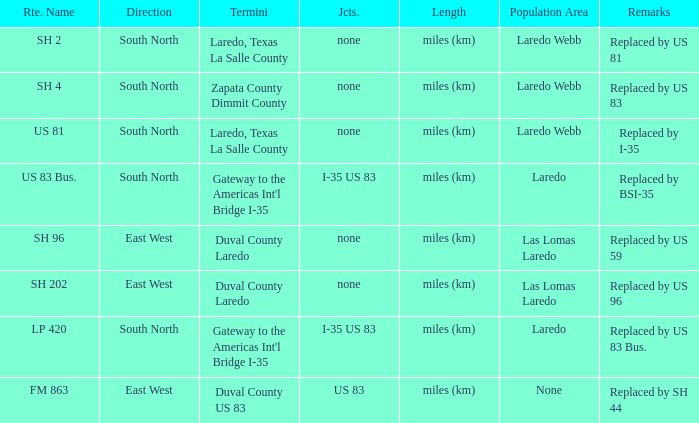How many termini are there that have "east west" listed in their direction section, "none" listed in their junction section, and have a route name of "sh 202"? 1.0. 